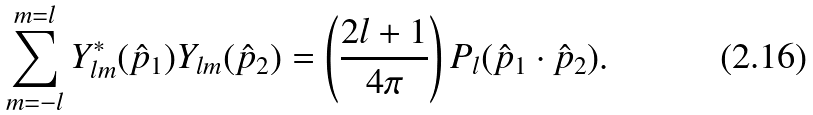<formula> <loc_0><loc_0><loc_500><loc_500>\sum _ { m = - l } ^ { m = l } Y _ { l m } ^ { * } ( \hat { p } _ { 1 } ) Y _ { l m } ( \hat { p } _ { 2 } ) = \left ( \frac { 2 l + 1 } { 4 \pi } \right ) P _ { l } ( \hat { p } _ { 1 } \cdot \hat { p } _ { 2 } ) .</formula> 